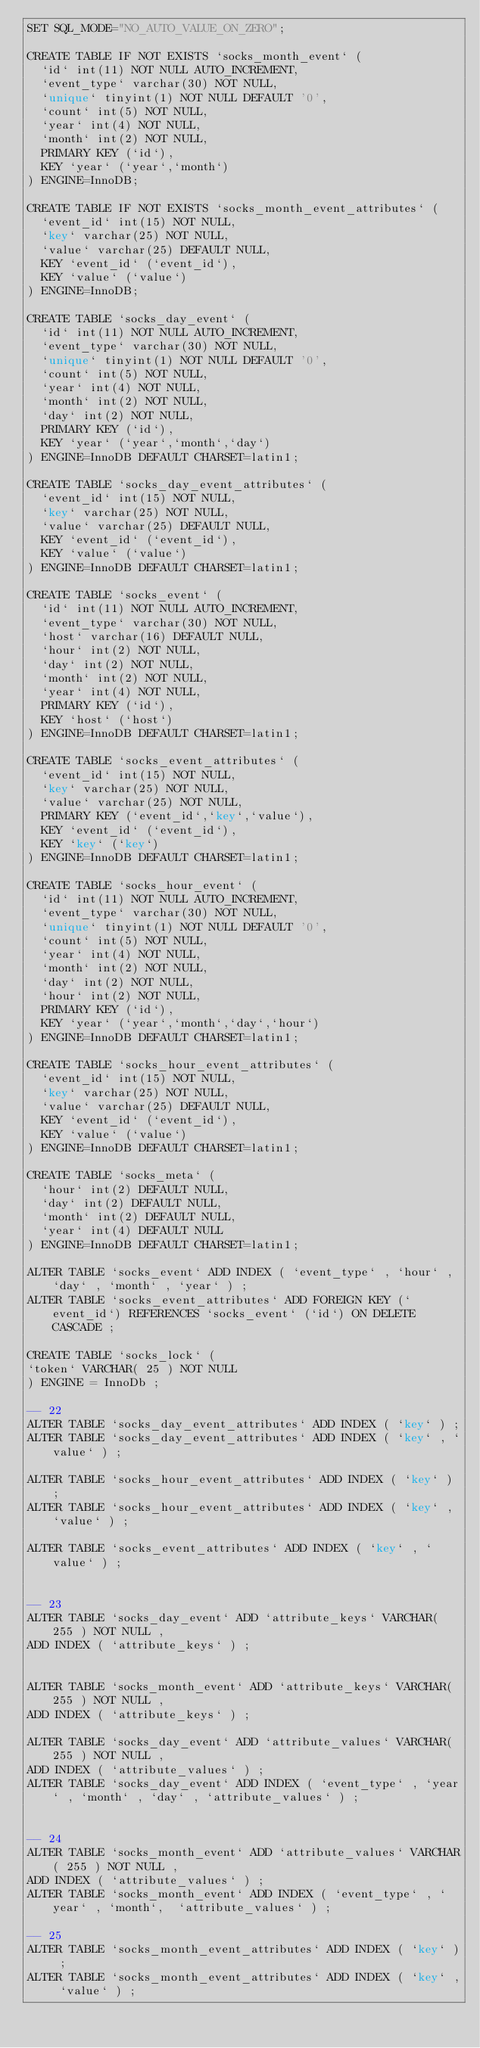Convert code to text. <code><loc_0><loc_0><loc_500><loc_500><_SQL_>SET SQL_MODE="NO_AUTO_VALUE_ON_ZERO";

CREATE TABLE IF NOT EXISTS `socks_month_event` (
  `id` int(11) NOT NULL AUTO_INCREMENT,
  `event_type` varchar(30) NOT NULL,
  `unique` tinyint(1) NOT NULL DEFAULT '0',
  `count` int(5) NOT NULL,
  `year` int(4) NOT NULL,
  `month` int(2) NOT NULL,
  PRIMARY KEY (`id`),
  KEY `year` (`year`,`month`)
) ENGINE=InnoDB;

CREATE TABLE IF NOT EXISTS `socks_month_event_attributes` (
  `event_id` int(15) NOT NULL,
  `key` varchar(25) NOT NULL,
  `value` varchar(25) DEFAULT NULL,
  KEY `event_id` (`event_id`),
  KEY `value` (`value`)
) ENGINE=InnoDB;

CREATE TABLE `socks_day_event` (
  `id` int(11) NOT NULL AUTO_INCREMENT,
  `event_type` varchar(30) NOT NULL,
  `unique` tinyint(1) NOT NULL DEFAULT '0',
  `count` int(5) NOT NULL,
  `year` int(4) NOT NULL,
  `month` int(2) NOT NULL,
  `day` int(2) NOT NULL,
  PRIMARY KEY (`id`),
  KEY `year` (`year`,`month`,`day`)
) ENGINE=InnoDB DEFAULT CHARSET=latin1;

CREATE TABLE `socks_day_event_attributes` (
  `event_id` int(15) NOT NULL,
  `key` varchar(25) NOT NULL,
  `value` varchar(25) DEFAULT NULL,
  KEY `event_id` (`event_id`),
  KEY `value` (`value`)
) ENGINE=InnoDB DEFAULT CHARSET=latin1;

CREATE TABLE `socks_event` (
  `id` int(11) NOT NULL AUTO_INCREMENT,
  `event_type` varchar(30) NOT NULL,
  `host` varchar(16) DEFAULT NULL,
  `hour` int(2) NOT NULL,
  `day` int(2) NOT NULL,
  `month` int(2) NOT NULL,
  `year` int(4) NOT NULL,
  PRIMARY KEY (`id`),
  KEY `host` (`host`)
) ENGINE=InnoDB DEFAULT CHARSET=latin1;

CREATE TABLE `socks_event_attributes` (
  `event_id` int(15) NOT NULL,
  `key` varchar(25) NOT NULL,
  `value` varchar(25) NOT NULL,
  PRIMARY KEY (`event_id`,`key`,`value`),
  KEY `event_id` (`event_id`),
  KEY `key` (`key`)
) ENGINE=InnoDB DEFAULT CHARSET=latin1;

CREATE TABLE `socks_hour_event` (
  `id` int(11) NOT NULL AUTO_INCREMENT,
  `event_type` varchar(30) NOT NULL,
  `unique` tinyint(1) NOT NULL DEFAULT '0',
  `count` int(5) NOT NULL,
  `year` int(4) NOT NULL,
  `month` int(2) NOT NULL,
  `day` int(2) NOT NULL,
  `hour` int(2) NOT NULL,
  PRIMARY KEY (`id`),
  KEY `year` (`year`,`month`,`day`,`hour`)
) ENGINE=InnoDB DEFAULT CHARSET=latin1;

CREATE TABLE `socks_hour_event_attributes` (
  `event_id` int(15) NOT NULL,
  `key` varchar(25) NOT NULL,
  `value` varchar(25) DEFAULT NULL,
  KEY `event_id` (`event_id`),
  KEY `value` (`value`)
) ENGINE=InnoDB DEFAULT CHARSET=latin1;

CREATE TABLE `socks_meta` (
  `hour` int(2) DEFAULT NULL,
  `day` int(2) DEFAULT NULL,
  `month` int(2) DEFAULT NULL,
  `year` int(4) DEFAULT NULL
) ENGINE=InnoDB DEFAULT CHARSET=latin1;

ALTER TABLE `socks_event` ADD INDEX ( `event_type` , `hour` , `day` , `month` , `year` ) ;
ALTER TABLE `socks_event_attributes` ADD FOREIGN KEY (`event_id`) REFERENCES `socks_event` (`id`) ON DELETE CASCADE ;

CREATE TABLE `socks_lock` (
`token` VARCHAR( 25 ) NOT NULL
) ENGINE = InnoDb ;

-- 22
ALTER TABLE `socks_day_event_attributes` ADD INDEX ( `key` ) ;
ALTER TABLE `socks_day_event_attributes` ADD INDEX ( `key` , `value` ) ;

ALTER TABLE `socks_hour_event_attributes` ADD INDEX ( `key` ) ;
ALTER TABLE `socks_hour_event_attributes` ADD INDEX ( `key` , `value` ) ;

ALTER TABLE `socks_event_attributes` ADD INDEX ( `key` , `value` ) ;


-- 23
ALTER TABLE `socks_day_event` ADD `attribute_keys` VARCHAR( 255 ) NOT NULL ,
ADD INDEX ( `attribute_keys` ) ;


ALTER TABLE `socks_month_event` ADD `attribute_keys` VARCHAR( 255 ) NOT NULL ,
ADD INDEX ( `attribute_keys` ) ;

ALTER TABLE `socks_day_event` ADD `attribute_values` VARCHAR( 255 ) NOT NULL ,
ADD INDEX ( `attribute_values` ) ;
ALTER TABLE `socks_day_event` ADD INDEX ( `event_type` , `year` , `month` , `day` , `attribute_values` ) ;


-- 24
ALTER TABLE `socks_month_event` ADD `attribute_values` VARCHAR( 255 ) NOT NULL ,
ADD INDEX ( `attribute_values` ) ;
ALTER TABLE `socks_month_event` ADD INDEX ( `event_type` , `year` , `month`,  `attribute_values` ) ;

-- 25
ALTER TABLE `socks_month_event_attributes` ADD INDEX ( `key` ) ;
ALTER TABLE `socks_month_event_attributes` ADD INDEX ( `key` , `value` ) ;</code> 